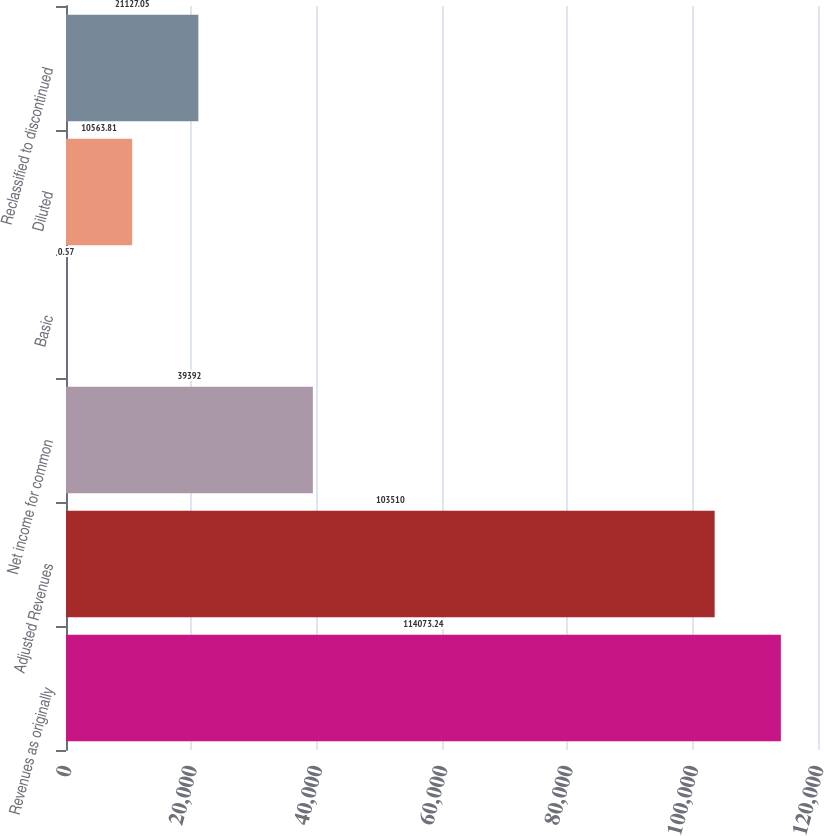<chart> <loc_0><loc_0><loc_500><loc_500><bar_chart><fcel>Revenues as originally<fcel>Adjusted Revenues<fcel>Net income for common<fcel>Basic<fcel>Diluted<fcel>Reclassified to discontinued<nl><fcel>114073<fcel>103510<fcel>39392<fcel>0.57<fcel>10563.8<fcel>21127<nl></chart> 